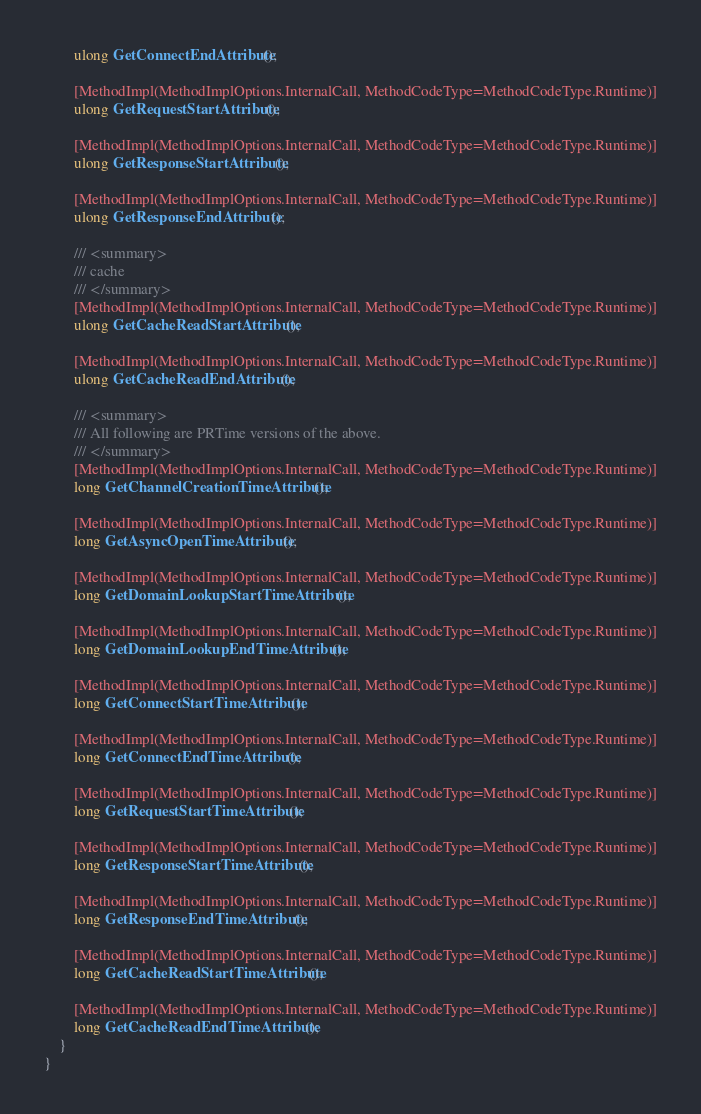<code> <loc_0><loc_0><loc_500><loc_500><_C#_>		ulong GetConnectEndAttribute();
		
		[MethodImpl(MethodImplOptions.InternalCall, MethodCodeType=MethodCodeType.Runtime)]
		ulong GetRequestStartAttribute();
		
		[MethodImpl(MethodImplOptions.InternalCall, MethodCodeType=MethodCodeType.Runtime)]
		ulong GetResponseStartAttribute();
		
		[MethodImpl(MethodImplOptions.InternalCall, MethodCodeType=MethodCodeType.Runtime)]
		ulong GetResponseEndAttribute();
		
		/// <summary>
        /// cache
        /// </summary>
		[MethodImpl(MethodImplOptions.InternalCall, MethodCodeType=MethodCodeType.Runtime)]
		ulong GetCacheReadStartAttribute();
		
		[MethodImpl(MethodImplOptions.InternalCall, MethodCodeType=MethodCodeType.Runtime)]
		ulong GetCacheReadEndAttribute();
		
		/// <summary>
        /// All following are PRTime versions of the above.
        /// </summary>
		[MethodImpl(MethodImplOptions.InternalCall, MethodCodeType=MethodCodeType.Runtime)]
		long GetChannelCreationTimeAttribute();
		
		[MethodImpl(MethodImplOptions.InternalCall, MethodCodeType=MethodCodeType.Runtime)]
		long GetAsyncOpenTimeAttribute();
		
		[MethodImpl(MethodImplOptions.InternalCall, MethodCodeType=MethodCodeType.Runtime)]
		long GetDomainLookupStartTimeAttribute();
		
		[MethodImpl(MethodImplOptions.InternalCall, MethodCodeType=MethodCodeType.Runtime)]
		long GetDomainLookupEndTimeAttribute();
		
		[MethodImpl(MethodImplOptions.InternalCall, MethodCodeType=MethodCodeType.Runtime)]
		long GetConnectStartTimeAttribute();
		
		[MethodImpl(MethodImplOptions.InternalCall, MethodCodeType=MethodCodeType.Runtime)]
		long GetConnectEndTimeAttribute();
		
		[MethodImpl(MethodImplOptions.InternalCall, MethodCodeType=MethodCodeType.Runtime)]
		long GetRequestStartTimeAttribute();
		
		[MethodImpl(MethodImplOptions.InternalCall, MethodCodeType=MethodCodeType.Runtime)]
		long GetResponseStartTimeAttribute();
		
		[MethodImpl(MethodImplOptions.InternalCall, MethodCodeType=MethodCodeType.Runtime)]
		long GetResponseEndTimeAttribute();
		
		[MethodImpl(MethodImplOptions.InternalCall, MethodCodeType=MethodCodeType.Runtime)]
		long GetCacheReadStartTimeAttribute();
		
		[MethodImpl(MethodImplOptions.InternalCall, MethodCodeType=MethodCodeType.Runtime)]
		long GetCacheReadEndTimeAttribute();
	}
}
</code> 